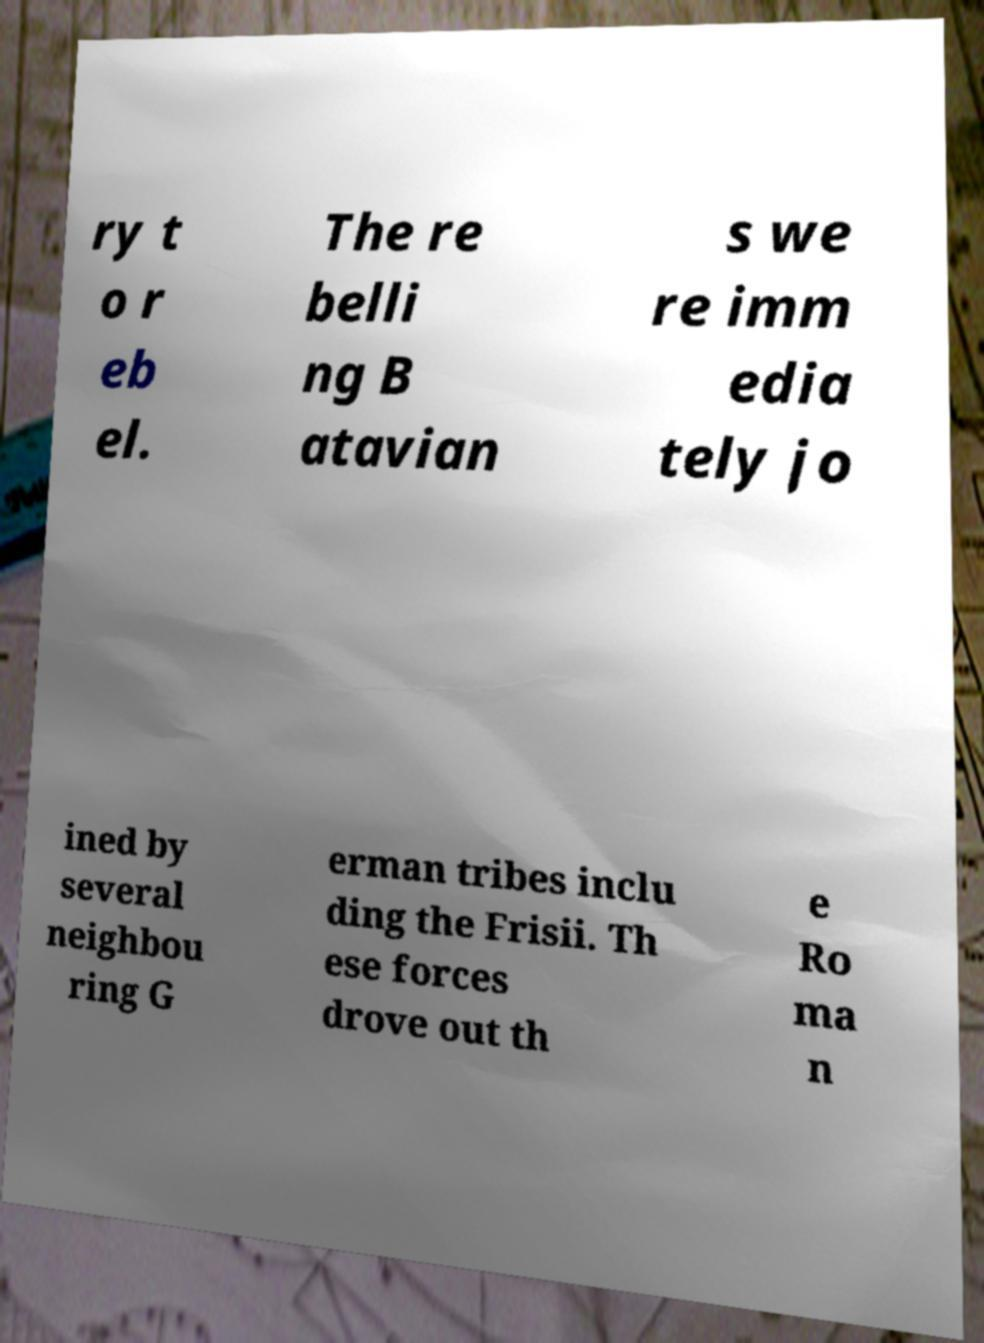For documentation purposes, I need the text within this image transcribed. Could you provide that? ry t o r eb el. The re belli ng B atavian s we re imm edia tely jo ined by several neighbou ring G erman tribes inclu ding the Frisii. Th ese forces drove out th e Ro ma n 